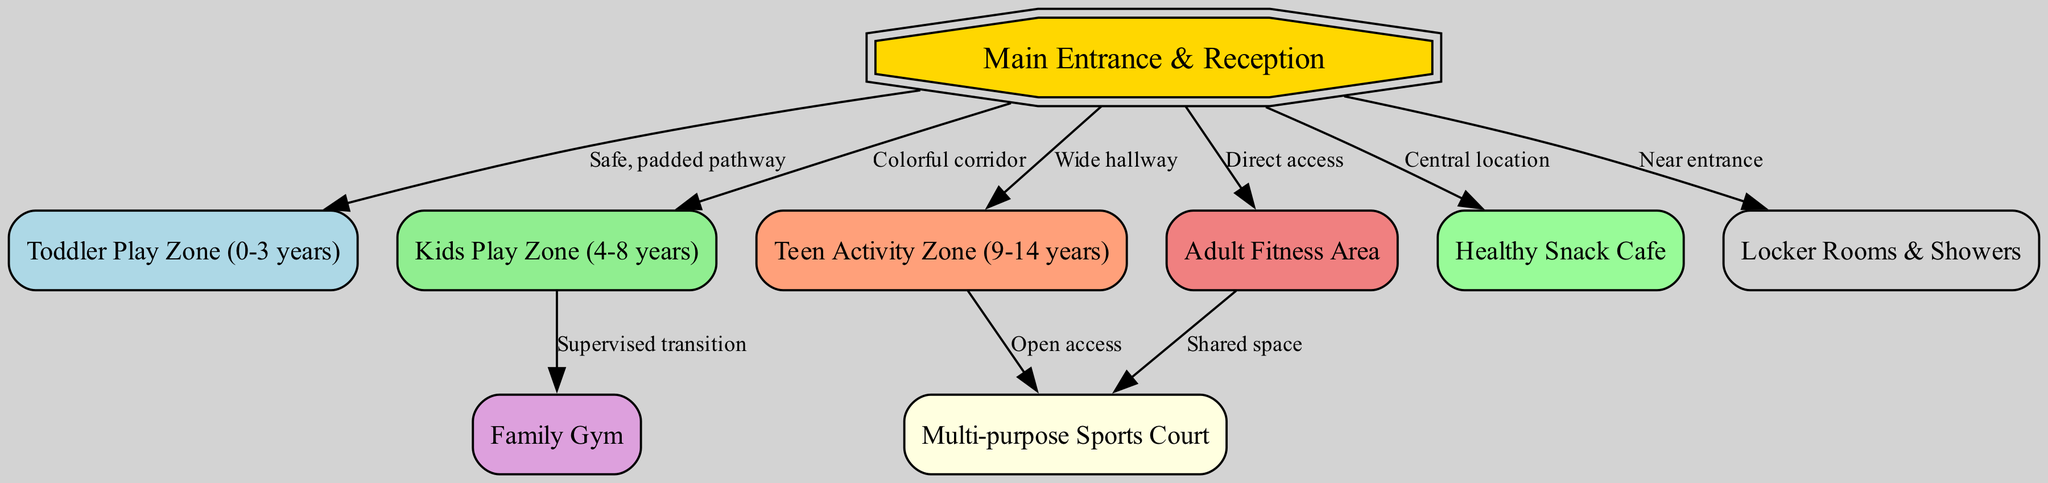What is the total number of nodes in the diagram? By counting each unique area represented in the diagram, we can find the total number of nodes. The nodes are: Main Entrance & Reception, Toddler Play Zone, Kids Play Zone, Teen Activity Zone, Adult Fitness Area, Family Gym, Multi-purpose Sports Court, Healthy Snack Cafe, and Locker Rooms & Showers. Counting these gives us a total of 9.
Answer: 9 Which zone is specifically designed for toddlers? The diagram identifies the "Toddler Play Zone (0-3 years)" as a dedicated area for toddlers, as labeled directly within the node representations.
Answer: Toddler Play Zone (0-3 years) How many edges are connected to the Main Entrance? By examining the connections from the Main Entrance node, we see three edges leading to the Toddler Zone, Kids Zone, Teen Zone, Adult Fitness Area, Cafe, and Locker Rooms. Counting these edges yields a total of 6.
Answer: 6 What type of pathway leads to the Toddler Play Zone? The diagram indicates a "Safe, padded pathway" leading to the Toddler Play Zone from the Main Entrance, defining the access type visually.
Answer: Safe, padded pathway Which zone is nearest to the Adult Fitness Area and accessible by a shared space? The connection from the Adult Fitness Area to the Multi-purpose Sports Court is identified in the diagram as a "Shared space", making it the nearest zone accessible from there.
Answer: Multi-purpose Sports Court What activity can teenagers access from their zone? The diagram showcases that teenagers from the Teen Activity Zone can access the Multi-purpose Sports Court, indicating a crossover between activities available for teens.
Answer: Multi-purpose Sports Court What is the color associated with the Kids Play Zone node? The node representing the Kids Play Zone is filled with "lightgreen" color as per the specifications for that area in the diagram.
Answer: lightgreen Which areas connect directly to the Main Entrance? Analyzing the diagram, we see direct connections from the Main Entrance to Toddler Zone, Kids Zone, Teen Zone, Adult Fitness Area, Cafe, and Locker Rooms. This provides a total of 6 areas connected to the Main Entrance.
Answer: Toddler Zone, Kids Zone, Teen Zone, Adult Fitness Area, Cafe, Locker Rooms What feature allows transition from the Kids Zone to the Family Gym? The diagram indicates "Supervised transition" as the connection feature available for moving from the Kids Zone to the Family Gym, ensuring safety as children switch areas.
Answer: Supervised transition 